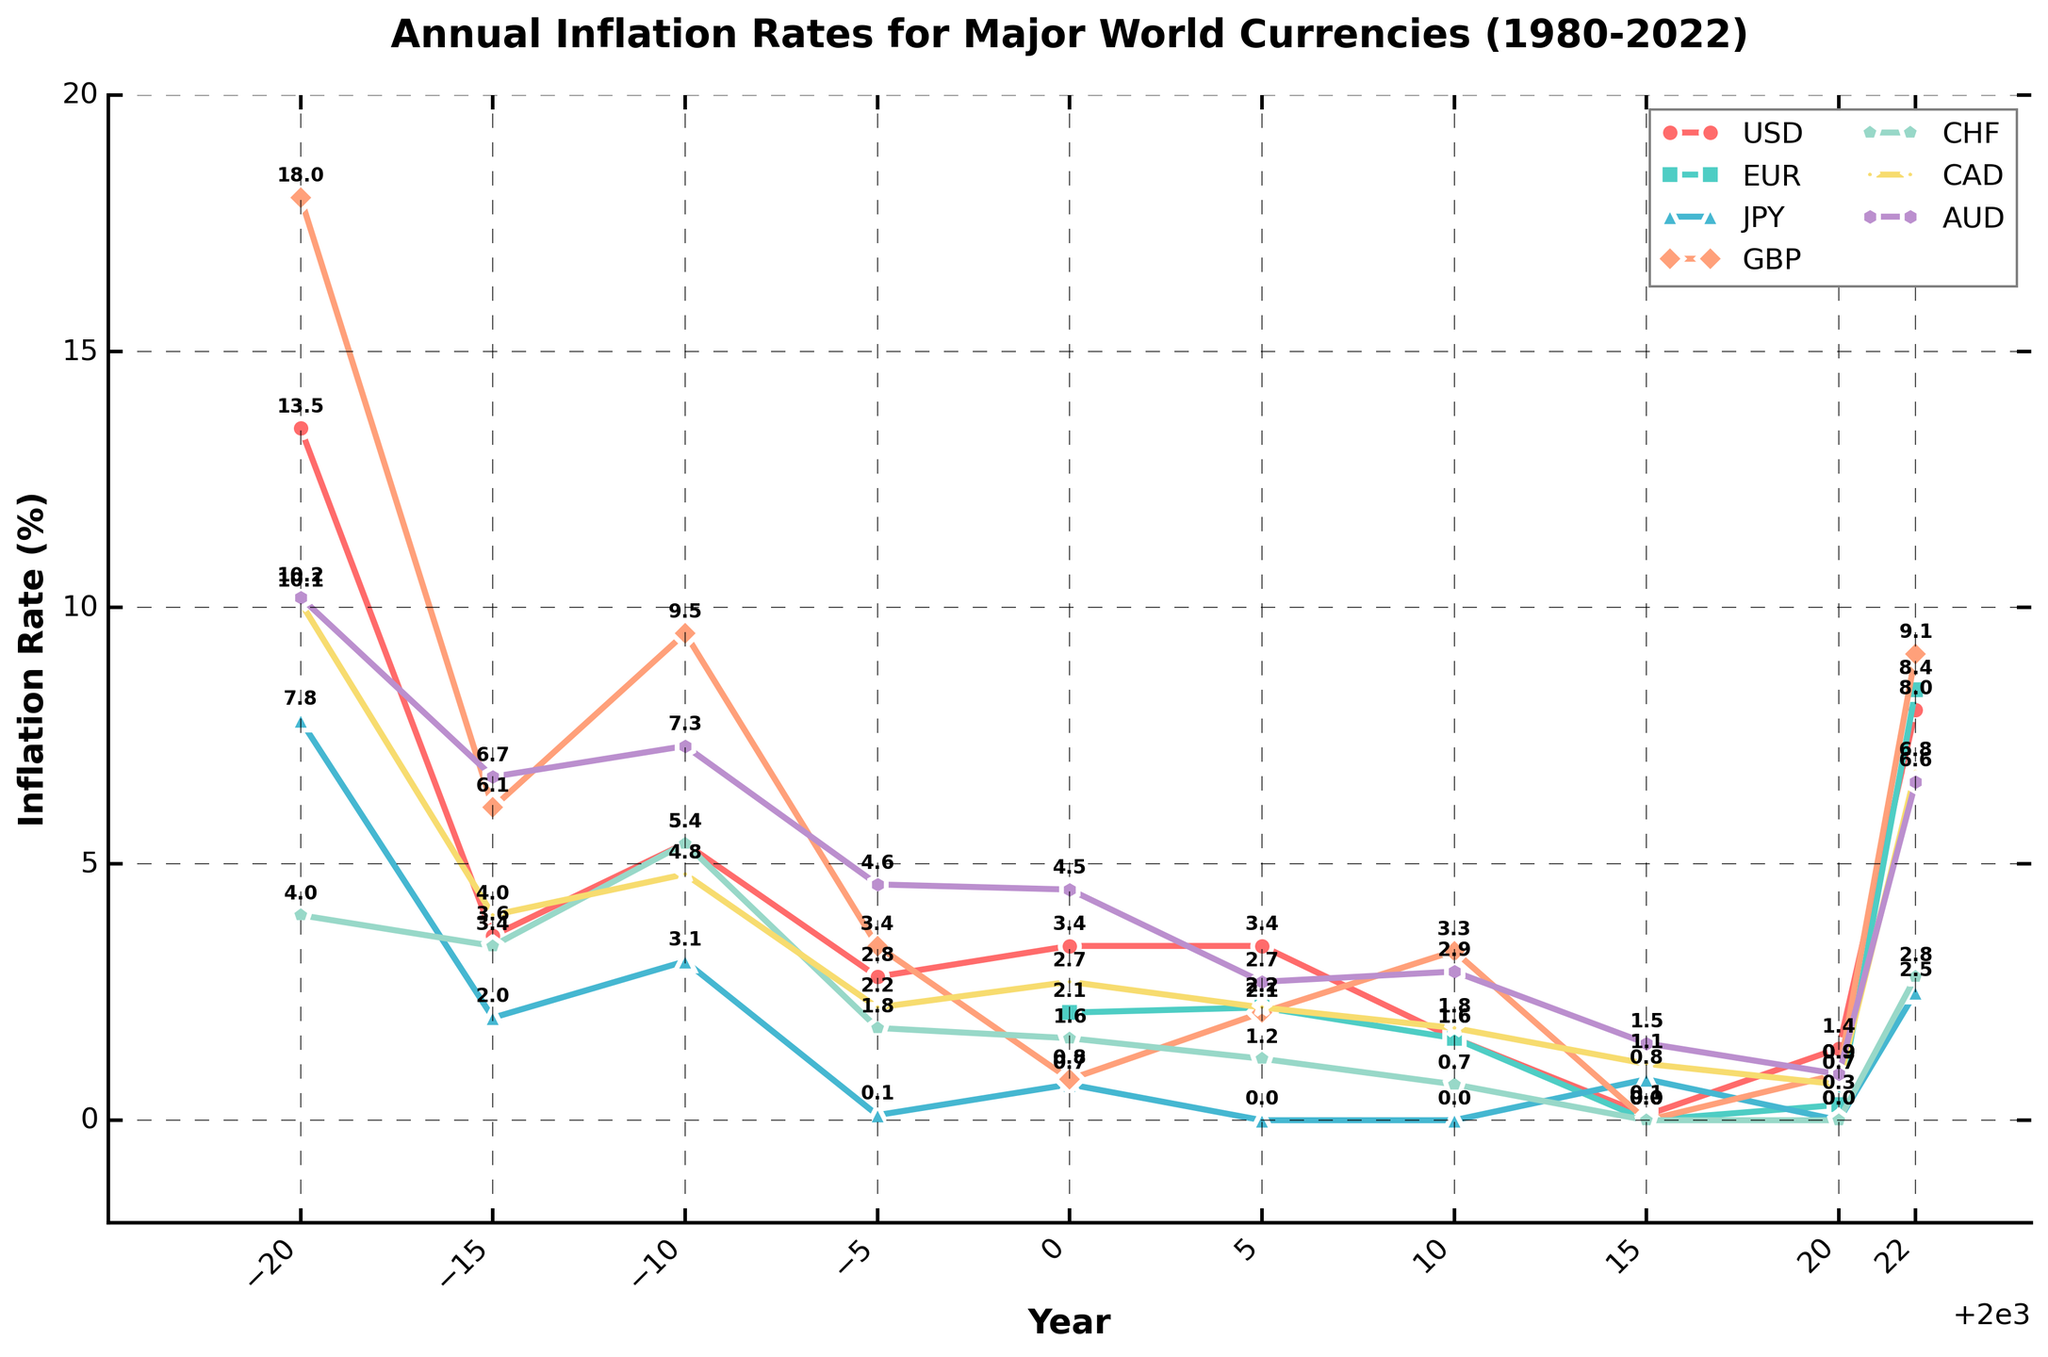What is the highest annual inflation rate for GBP from 1980 to 2022? The plot shows varying inflation rates for GBP over the years. To find the highest rate, identify the peak point for GBP's marker line. The highest inflation rate for GBP is in 1980 with a rate of 18.0%.
Answer: 18.0% Which year had the lowest inflation rate for both USD and JPY? To find the lowest inflation rates for each currency, look for the lowest points on the respective marker lines for USD and JPY. For the USD, the lowest inflation rate is in 2015 with 0.1%. For JPY, the lowest rate is in 2005 and 2010 with 0.0%. The common lowest year across both is 2010.
Answer: 2010 Between EUR and CAD, which had a higher inflation rate in 2005? Comparing the heights of EUR and CAD markers in 2005, EUR has an inflation rate of 2.2% while CAD has 2.2%. Thus, both have the same inflation rate in 2005.
Answer: equal What is the average inflation rate for CHF over the years 2000, 2005, and 2010? To calculate the average, sum the inflation rates for CHF in the given years and divide by the number of years: (1.6 + 1.2 + 0.7) / 3 = 1.1667%.
Answer: 1.2% How does the inflation rate change for AUD from 1985 to 1990? Check the plot points for AUD in 1985 (6.7%) and 1990 (7.3%). The rate increases from 6.7% to 7.3%, indicating a rise of 0.6%.
Answer: increased by 0.6% Which currency had the most stable inflation rate over the entire period? Stability can be gauged by the least fluctuation in the marker positions over time. JPY shows the least fluctuation and remains close to 0.0% inflation for many years.
Answer: JPY In 2022, which currency experienced the highest inflation rate, and what was its value? Checking the plot markers for all currencies in 2022, GBP had a peak inflation rate of 9.1%.
Answer: GBP, 9.1% What is the difference in inflation rates between CHF and USD in 2022? Find the inflation rates for CHF (2.8%) and USD (8.0%) in 2022, and compute the difference: 8.0% - 2.8% = 5.2%.
Answer: 5.2% If you average the inflation rates for EUR in 2000 and 2022, what value do you get? Average the inflation rates for EUR in 2000 (2.1%) and 2022 (8.4%): (2.1 + 8.4) / 2 = 5.25%.
Answer: 5.3% In which year did CAD have an inflation rate higher than USD but lower than GBP? Analyze the inflation rates in all years where CAD falls between USD and GBP. In 1990, CAD (4.8%) is higher than USD (5.4%) and lower than GBP (9.5%).
Answer: 1990 